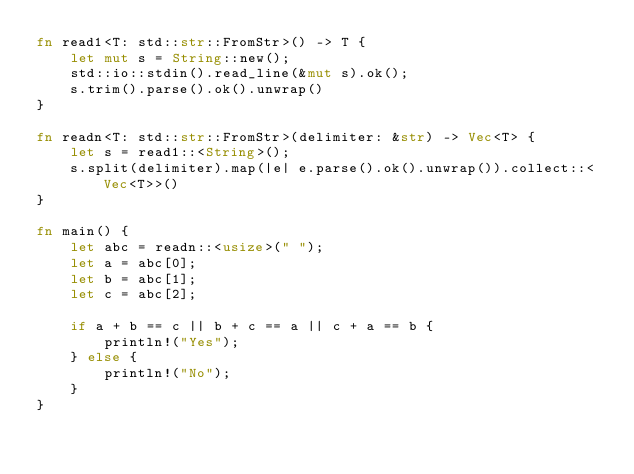<code> <loc_0><loc_0><loc_500><loc_500><_Rust_>fn read1<T: std::str::FromStr>() -> T {
    let mut s = String::new();
    std::io::stdin().read_line(&mut s).ok();
    s.trim().parse().ok().unwrap()
}

fn readn<T: std::str::FromStr>(delimiter: &str) -> Vec<T> {
    let s = read1::<String>();
    s.split(delimiter).map(|e| e.parse().ok().unwrap()).collect::<Vec<T>>()
}

fn main() {
    let abc = readn::<usize>(" ");
    let a = abc[0];
    let b = abc[1];
    let c = abc[2];

    if a + b == c || b + c == a || c + a == b {
        println!("Yes");
    } else {
        println!("No");
    }
}</code> 